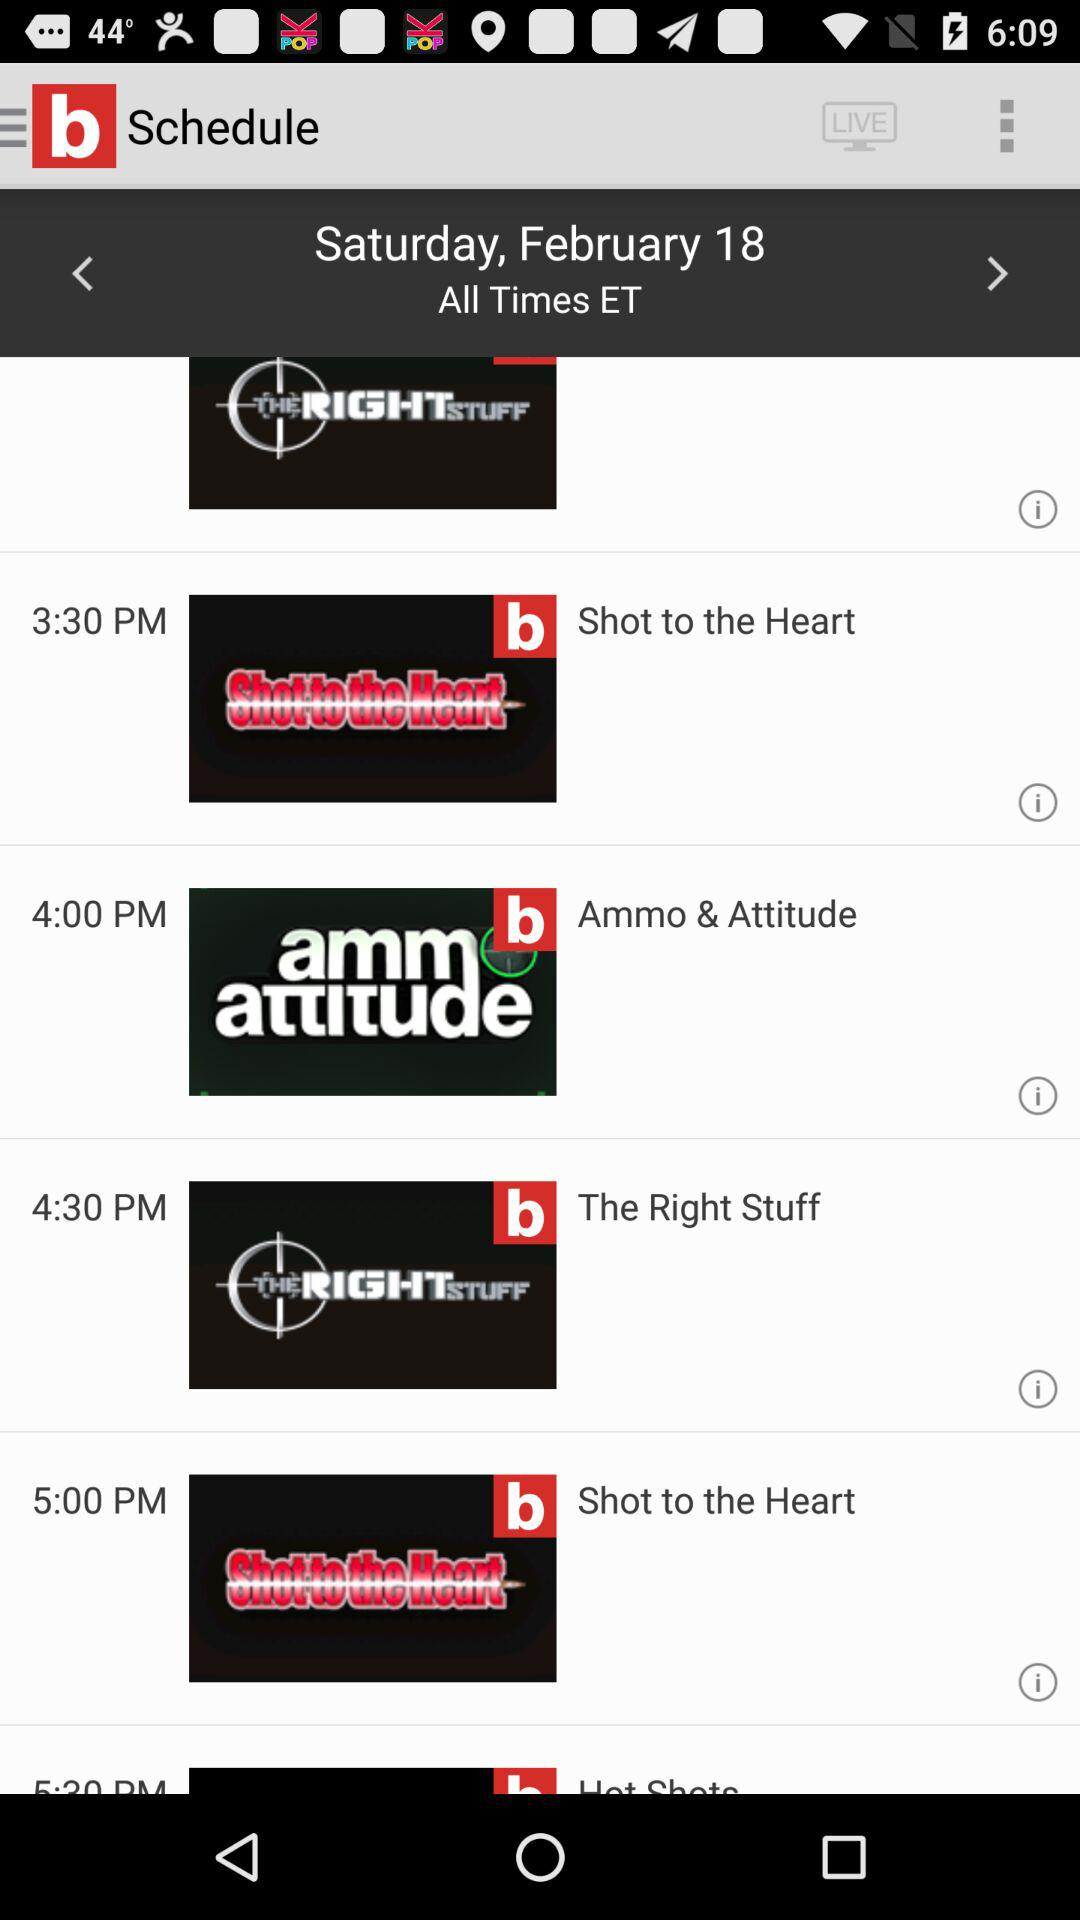Which show is broadcast at 4:30 p.m.? The show "The Right Stuff" is broadcast at 4:30 p.m. 